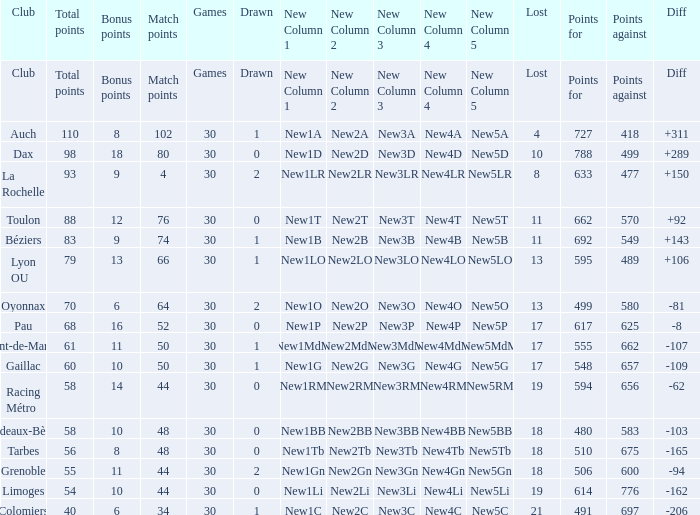What is the diff for a club that has a value of 662 for points for? 92.0. 